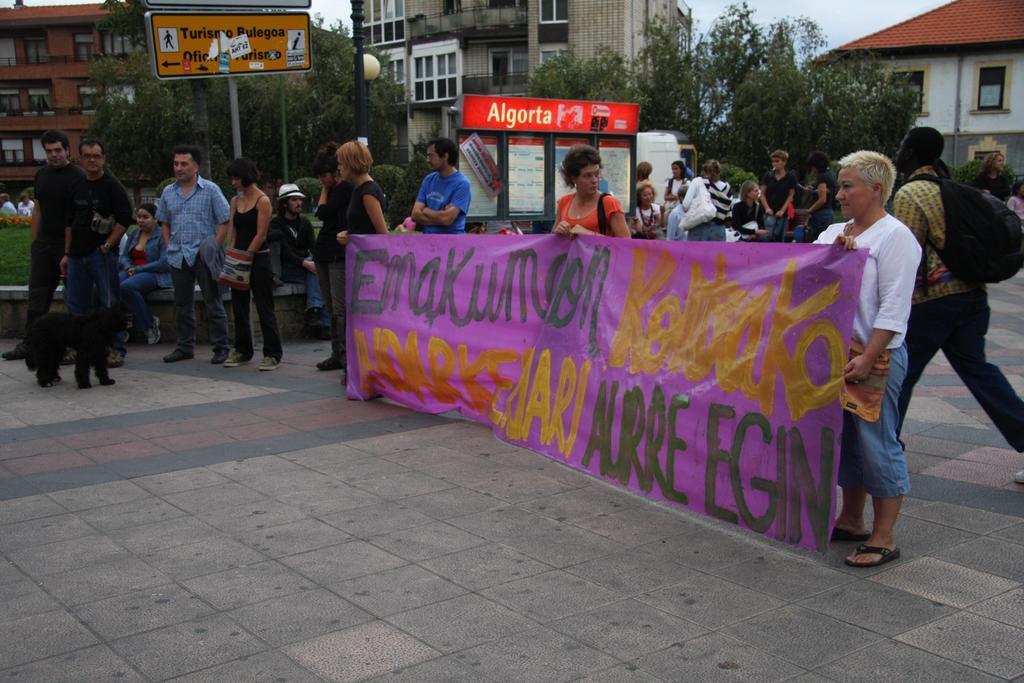Where was the image taken? The image was taken on a road. What are the three persons in the image doing? The three persons are holding a banner. Where are the three persons standing? The three persons are standing on the road. What can be seen in the background of the image? There are buildings, trees, and boards in the background of the image. Reasoning: Let' Let's think step by step in order to produce the conversation. We start by identifying the location of the image, which is on a road. Then, we describe the actions of the three persons in the image, who are holding a banner. Next, we specify where the persons are standing, which is on the road. Finally, we mention the various elements visible in the background of the image, including buildings, trees, and boards. Absurd Question/Answer: How many jellyfish can be seen swimming in the background of the image? There are no jellyfish present in the image; it is taken on a road with buildings, trees, and boards in the background. What type of pest is crawling on the banner in the image? There are no pests visible on the banner in the image. 